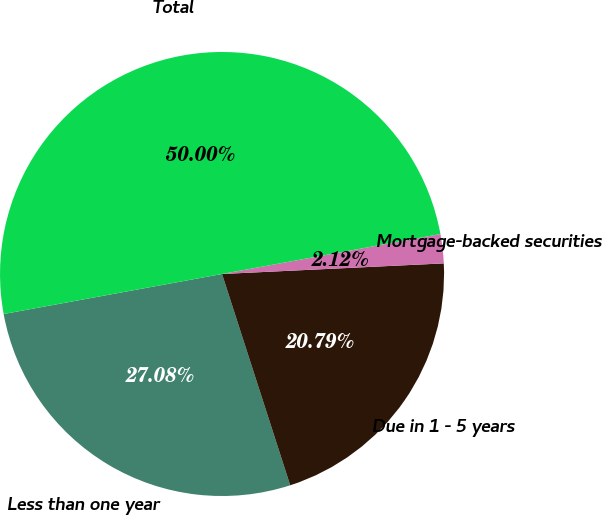Convert chart. <chart><loc_0><loc_0><loc_500><loc_500><pie_chart><fcel>Less than one year<fcel>Due in 1 - 5 years<fcel>Mortgage-backed securities<fcel>Total<nl><fcel>27.08%<fcel>20.79%<fcel>2.12%<fcel>50.0%<nl></chart> 